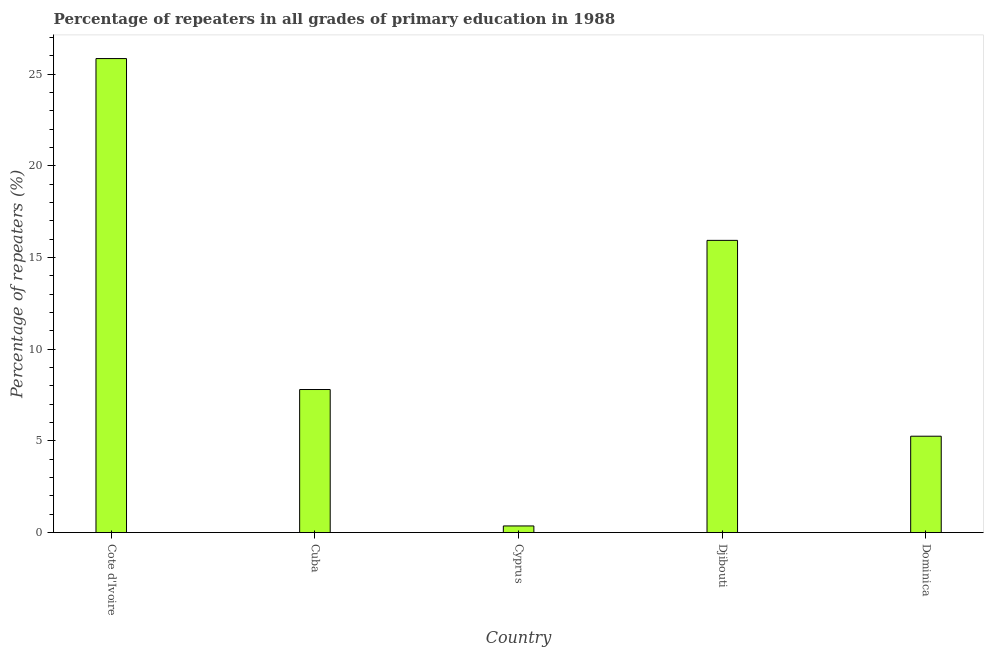What is the title of the graph?
Offer a very short reply. Percentage of repeaters in all grades of primary education in 1988. What is the label or title of the Y-axis?
Keep it short and to the point. Percentage of repeaters (%). What is the percentage of repeaters in primary education in Dominica?
Provide a short and direct response. 5.25. Across all countries, what is the maximum percentage of repeaters in primary education?
Give a very brief answer. 25.84. Across all countries, what is the minimum percentage of repeaters in primary education?
Your response must be concise. 0.36. In which country was the percentage of repeaters in primary education maximum?
Offer a very short reply. Cote d'Ivoire. In which country was the percentage of repeaters in primary education minimum?
Make the answer very short. Cyprus. What is the sum of the percentage of repeaters in primary education?
Provide a succinct answer. 55.19. What is the difference between the percentage of repeaters in primary education in Djibouti and Dominica?
Offer a very short reply. 10.68. What is the average percentage of repeaters in primary education per country?
Provide a succinct answer. 11.04. What is the median percentage of repeaters in primary education?
Offer a very short reply. 7.8. In how many countries, is the percentage of repeaters in primary education greater than 4 %?
Give a very brief answer. 4. What is the ratio of the percentage of repeaters in primary education in Cyprus to that in Dominica?
Make the answer very short. 0.07. Is the difference between the percentage of repeaters in primary education in Cote d'Ivoire and Djibouti greater than the difference between any two countries?
Offer a very short reply. No. What is the difference between the highest and the second highest percentage of repeaters in primary education?
Keep it short and to the point. 9.91. Is the sum of the percentage of repeaters in primary education in Cote d'Ivoire and Cuba greater than the maximum percentage of repeaters in primary education across all countries?
Make the answer very short. Yes. What is the difference between the highest and the lowest percentage of repeaters in primary education?
Your answer should be compact. 25.48. In how many countries, is the percentage of repeaters in primary education greater than the average percentage of repeaters in primary education taken over all countries?
Provide a short and direct response. 2. How many bars are there?
Provide a succinct answer. 5. Are all the bars in the graph horizontal?
Your answer should be compact. No. What is the Percentage of repeaters (%) in Cote d'Ivoire?
Provide a succinct answer. 25.84. What is the Percentage of repeaters (%) of Cuba?
Your answer should be compact. 7.8. What is the Percentage of repeaters (%) of Cyprus?
Your response must be concise. 0.36. What is the Percentage of repeaters (%) of Djibouti?
Offer a terse response. 15.93. What is the Percentage of repeaters (%) of Dominica?
Provide a short and direct response. 5.25. What is the difference between the Percentage of repeaters (%) in Cote d'Ivoire and Cuba?
Your answer should be compact. 18.04. What is the difference between the Percentage of repeaters (%) in Cote d'Ivoire and Cyprus?
Offer a very short reply. 25.48. What is the difference between the Percentage of repeaters (%) in Cote d'Ivoire and Djibouti?
Provide a succinct answer. 9.91. What is the difference between the Percentage of repeaters (%) in Cote d'Ivoire and Dominica?
Give a very brief answer. 20.59. What is the difference between the Percentage of repeaters (%) in Cuba and Cyprus?
Provide a short and direct response. 7.44. What is the difference between the Percentage of repeaters (%) in Cuba and Djibouti?
Keep it short and to the point. -8.13. What is the difference between the Percentage of repeaters (%) in Cuba and Dominica?
Offer a very short reply. 2.55. What is the difference between the Percentage of repeaters (%) in Cyprus and Djibouti?
Your response must be concise. -15.57. What is the difference between the Percentage of repeaters (%) in Cyprus and Dominica?
Offer a terse response. -4.89. What is the difference between the Percentage of repeaters (%) in Djibouti and Dominica?
Provide a succinct answer. 10.68. What is the ratio of the Percentage of repeaters (%) in Cote d'Ivoire to that in Cuba?
Make the answer very short. 3.31. What is the ratio of the Percentage of repeaters (%) in Cote d'Ivoire to that in Cyprus?
Your answer should be very brief. 71.26. What is the ratio of the Percentage of repeaters (%) in Cote d'Ivoire to that in Djibouti?
Offer a terse response. 1.62. What is the ratio of the Percentage of repeaters (%) in Cote d'Ivoire to that in Dominica?
Offer a terse response. 4.92. What is the ratio of the Percentage of repeaters (%) in Cuba to that in Cyprus?
Your response must be concise. 21.51. What is the ratio of the Percentage of repeaters (%) in Cuba to that in Djibouti?
Give a very brief answer. 0.49. What is the ratio of the Percentage of repeaters (%) in Cuba to that in Dominica?
Make the answer very short. 1.48. What is the ratio of the Percentage of repeaters (%) in Cyprus to that in Djibouti?
Make the answer very short. 0.02. What is the ratio of the Percentage of repeaters (%) in Cyprus to that in Dominica?
Give a very brief answer. 0.07. What is the ratio of the Percentage of repeaters (%) in Djibouti to that in Dominica?
Give a very brief answer. 3.03. 